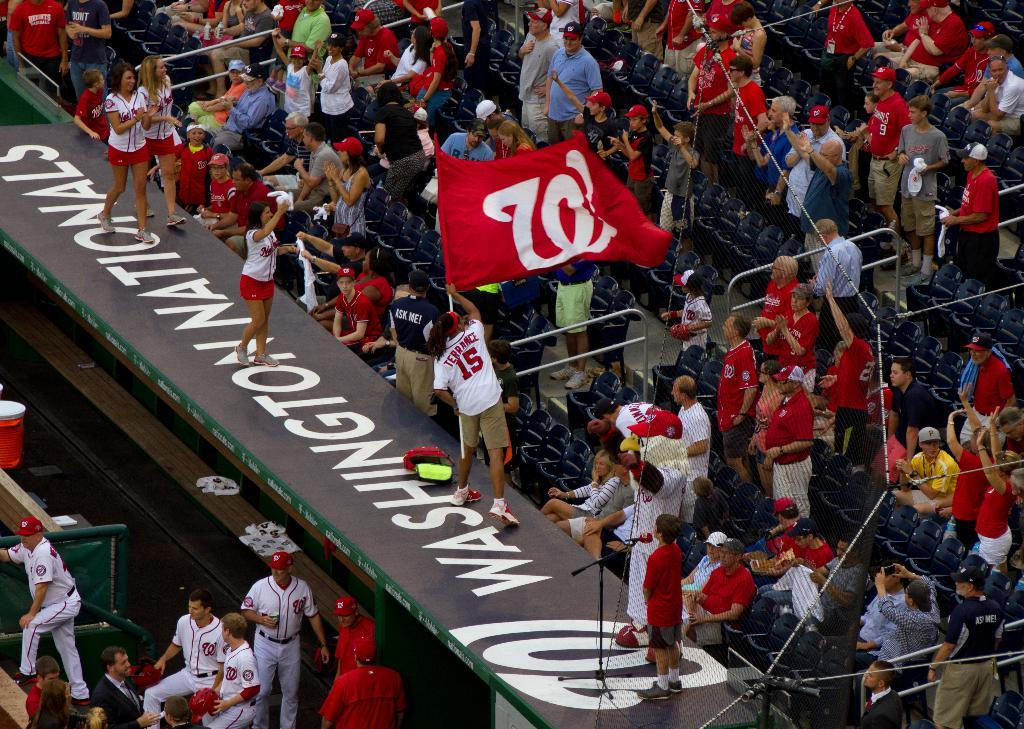<image>
Provide a brief description of the given image. Washington Nationals baseball stadium with its fan cheering on the Nationals. 